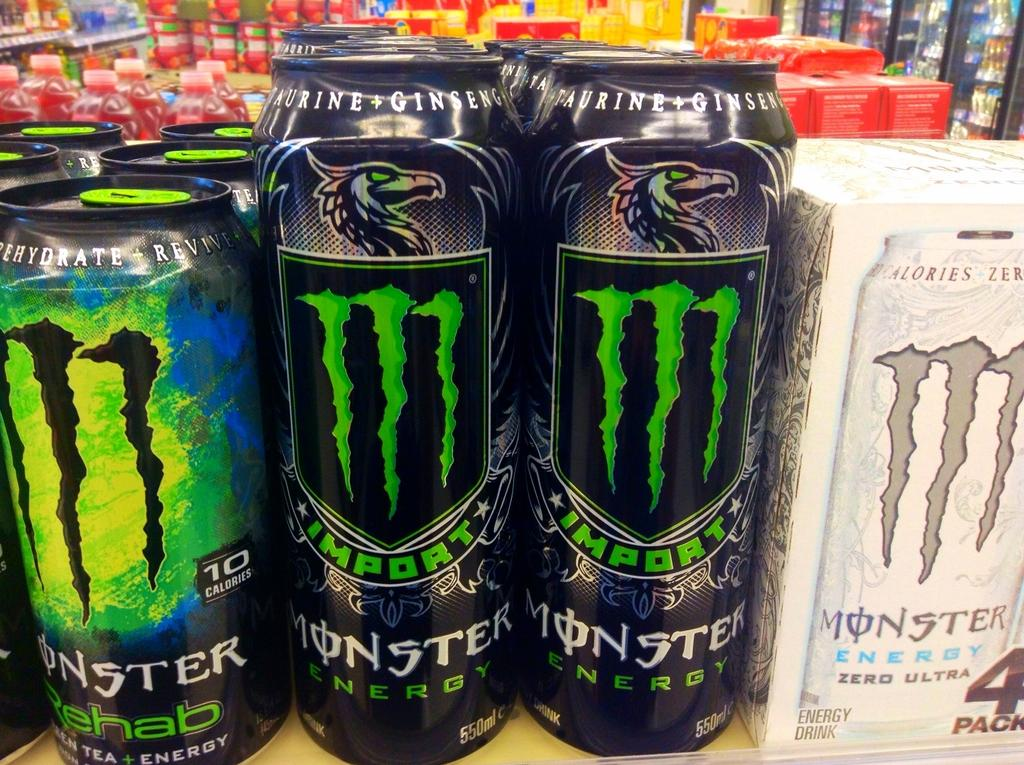<image>
Describe the image concisely. Cans of Monster Energy Drink and a 4 pack box of such on a shelf. 